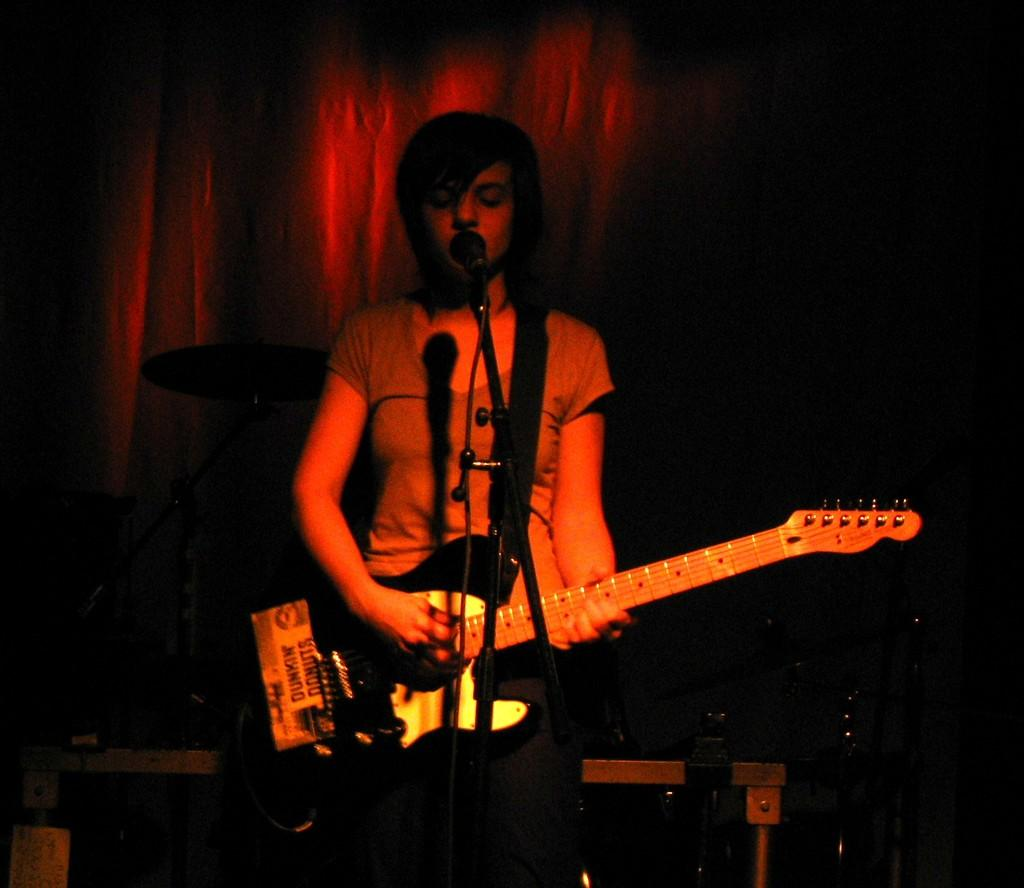What is the person in the image doing? The person is standing in the image and holding a guitar in their hand. What is the person wearing? The person is wearing clothes. What object can be seen near the person? There is a microphone in the image. What type of objects are present in the image? There are objects in the image, including a guitar and a microphone. What can be seen in the background of the image? There are curtains in the image. What song is the person singing in the image? There is no indication in the image that the person is singing, and therefore no song can be identified. 